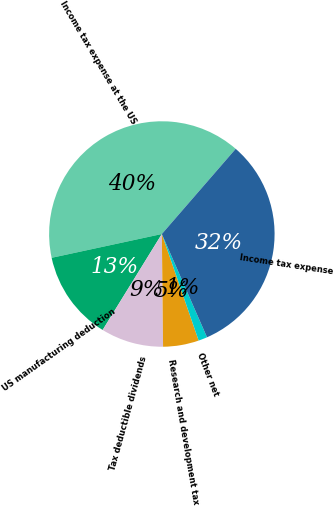Convert chart. <chart><loc_0><loc_0><loc_500><loc_500><pie_chart><fcel>Income tax expense at the US<fcel>US manufacturing deduction<fcel>Tax deductible dividends<fcel>Research and development tax<fcel>Other net<fcel>Income tax expense<nl><fcel>39.76%<fcel>12.82%<fcel>8.97%<fcel>5.12%<fcel>1.27%<fcel>32.07%<nl></chart> 